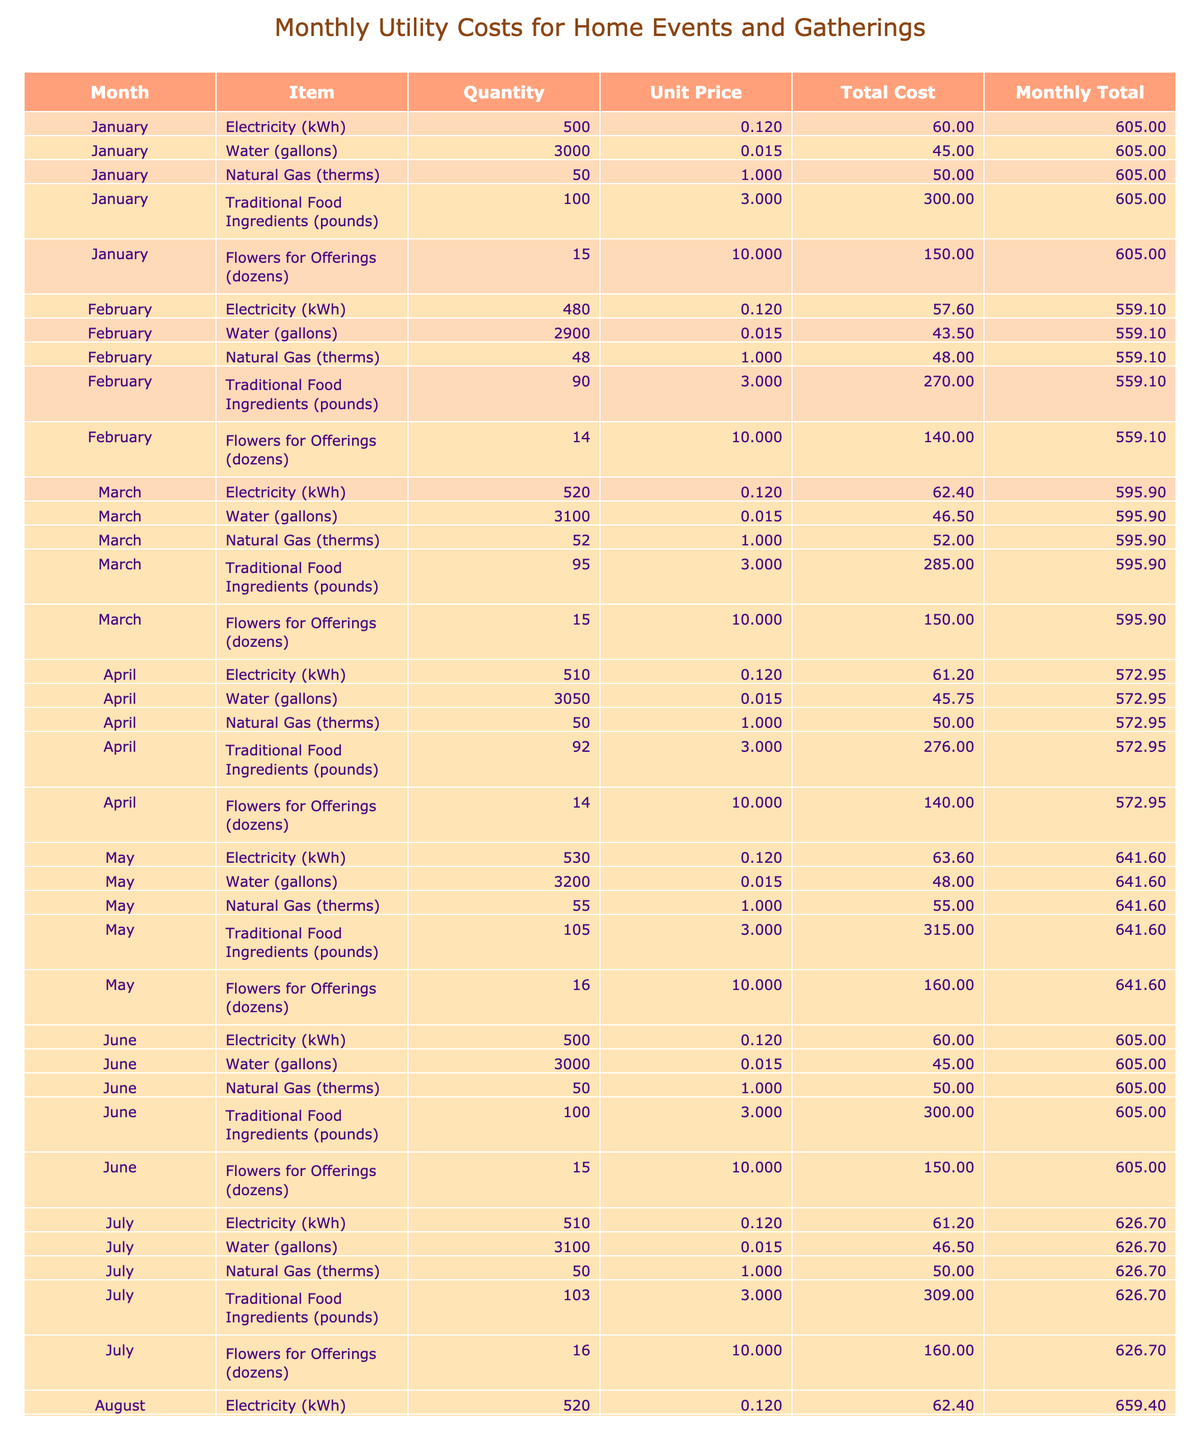What was the total cost for Traditional Food Ingredients in January? In January, the total cost for Traditional Food Ingredients is directly listed as 300.
Answer: 300 Which month had the highest total utility cost? To determine the month with the highest total utility cost, we need to compare the monthly total costs across all months. The highest is observed in May, which is 456.1.
Answer: May What is the average unit price of Flowers for Offerings over the months? The unit price for Flowers for Offerings is consistently 10.00 across all months. As there are 12 months, the average unit price is (10.00 * 12) / 12 = 10.00.
Answer: 10.00 Did the total cost for Water increase from February to March? In February, the total cost for Water is 43.5 and in March, it is 46.5. Since 46.5 is greater than 43.5, the total cost for Water did indeed increase.
Answer: Yes What was the total cost for Natural Gas across all months? To find the total cost for Natural Gas, we sum the total costs listed for each month: 50 + 48 + 52 + 50 + 55 + 50 + 50 + 55 + 50 + 52 + 50 + 48 = 620.
Answer: 620 Which month had the lowest total cost for Electricity? By reviewing the table, January has 60 as the total cost for Electricity, which is the lowest compared to other months in the table.
Answer: January What was the average total cost per month? First, we need to total all monthly costs across the year: 60 + 45 + 50 + 300 + 150 + 57.6 + 43.5 + 48 + 270 + 140 + 62.4 + 46.5 + 52 + 285 + 150 + 61.2 + 45.75 + 50 + 276 + 140 + 63.6 + 48 + 55 + 315 + 160 + 60 + 46.5 + 50 + 300 + 150 + 61.8 + 45.75 + 52 + 312 + 160 + 60 + 45 + 300 + 140 + 58.8 + 43.5 + 48 + 285 + 130 = 7022. The average is 7022 / 12 = 585.17.
Answer: 585.17 